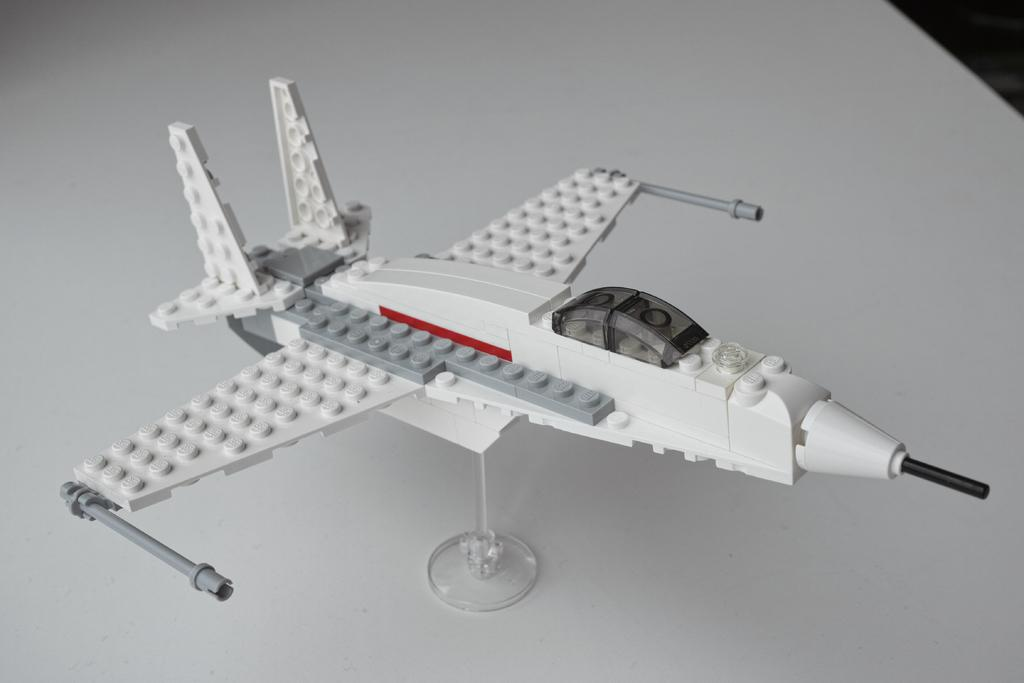What is the main subject of the image? The main subject of the image is a lego aeroplane. Where is the lego aeroplane located? The lego aeroplane is on a white table. What type of corn can be seen growing on the plantation in the image? There is no corn or plantation present in the image; it features a lego aeroplane on a white table. How many sponges are visible in the image? There are no sponges visible in the image. 